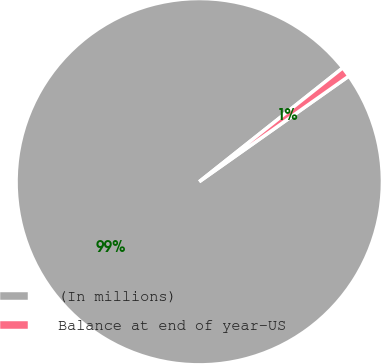Convert chart. <chart><loc_0><loc_0><loc_500><loc_500><pie_chart><fcel>(In millions)<fcel>Balance at end of year-US<nl><fcel>99.11%<fcel>0.89%<nl></chart> 